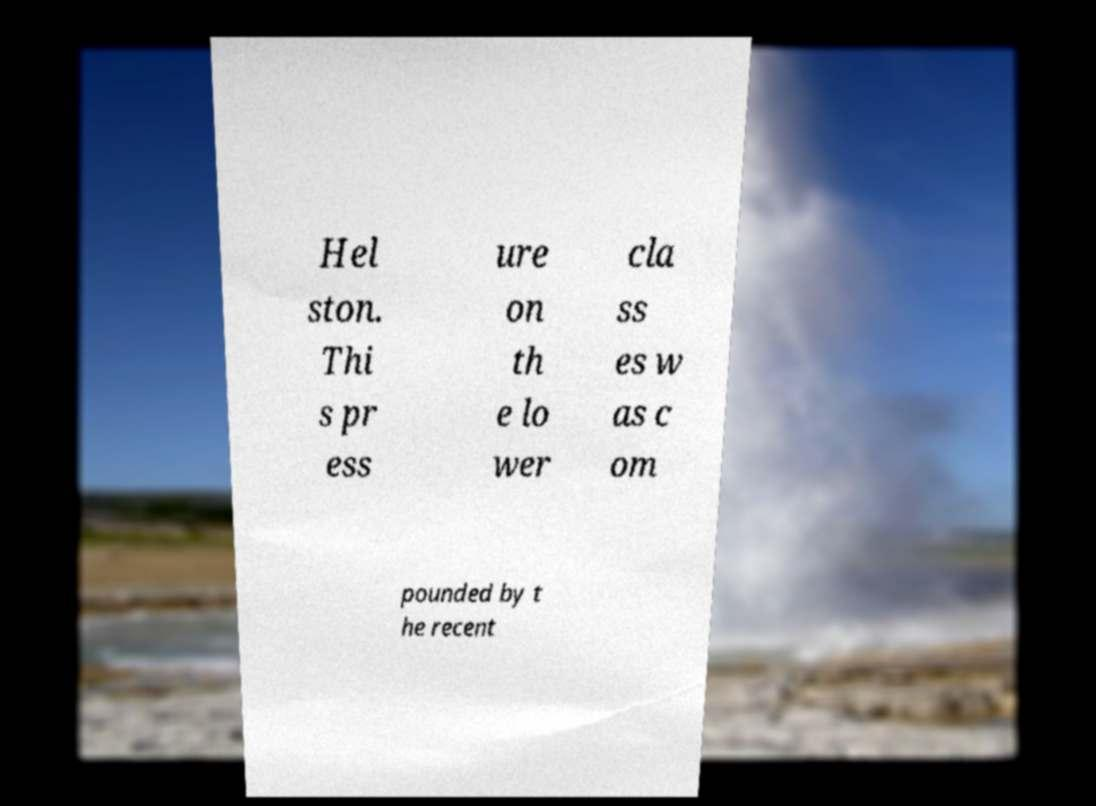Could you assist in decoding the text presented in this image and type it out clearly? Hel ston. Thi s pr ess ure on th e lo wer cla ss es w as c om pounded by t he recent 